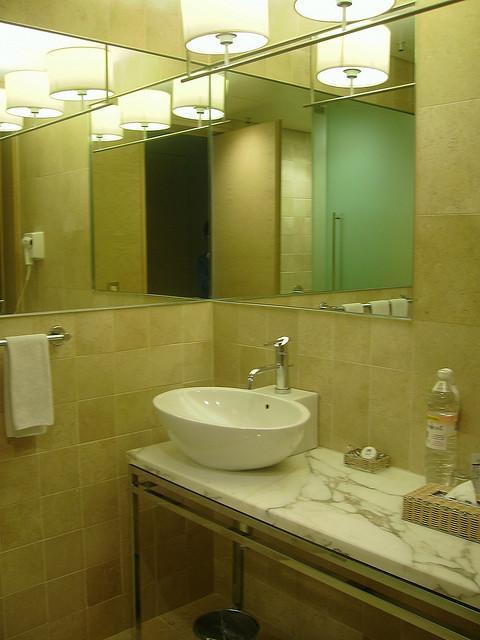How many mirrors are there?
Give a very brief answer. 2. 